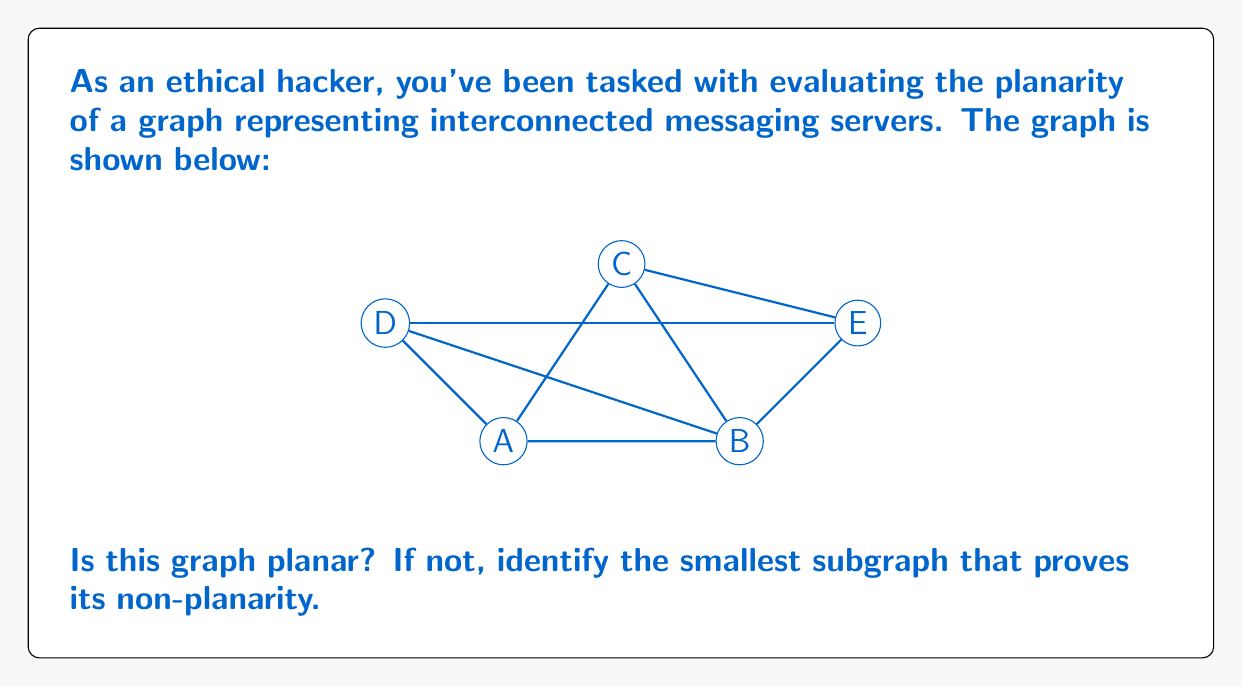Could you help me with this problem? To determine if the given graph is planar, we can use Kuratowski's theorem, which states that a graph is planar if and only if it does not contain a subgraph that is a subdivision of $K_5$ (complete graph on 5 vertices) or $K_{3,3}$ (complete bipartite graph on 3+3 vertices).

Let's analyze the graph:

1) The graph has 5 vertices (A, B, C, D, E) and 8 edges.

2) We can observe that this graph contains a subgraph isomorphic to $K_{3,3}$:
   - Set 1: {A, C, E}
   - Set 2: {B, D}
   
   Every vertex in Set 1 is connected to every vertex in Set 2, except for the edge (A,D).

3) To complete the $K_{3,3}$ subgraph, we need to add the edge (A,D), which is already present in our original graph.

4) Therefore, our graph contains a $K_{3,3}$ subgraph, which is:
   A-B, A-D, C-B, C-D, E-B, E-D

According to Kuratowski's theorem, since the graph contains a $K_{3,3}$ subgraph, it is not planar.

The smallest subgraph that proves non-planarity is this $K_{3,3}$ subgraph with 6 vertices and 9 edges.
Answer: Not planar; $K_{3,3}$ subgraph: A-B-C-D-E-B 